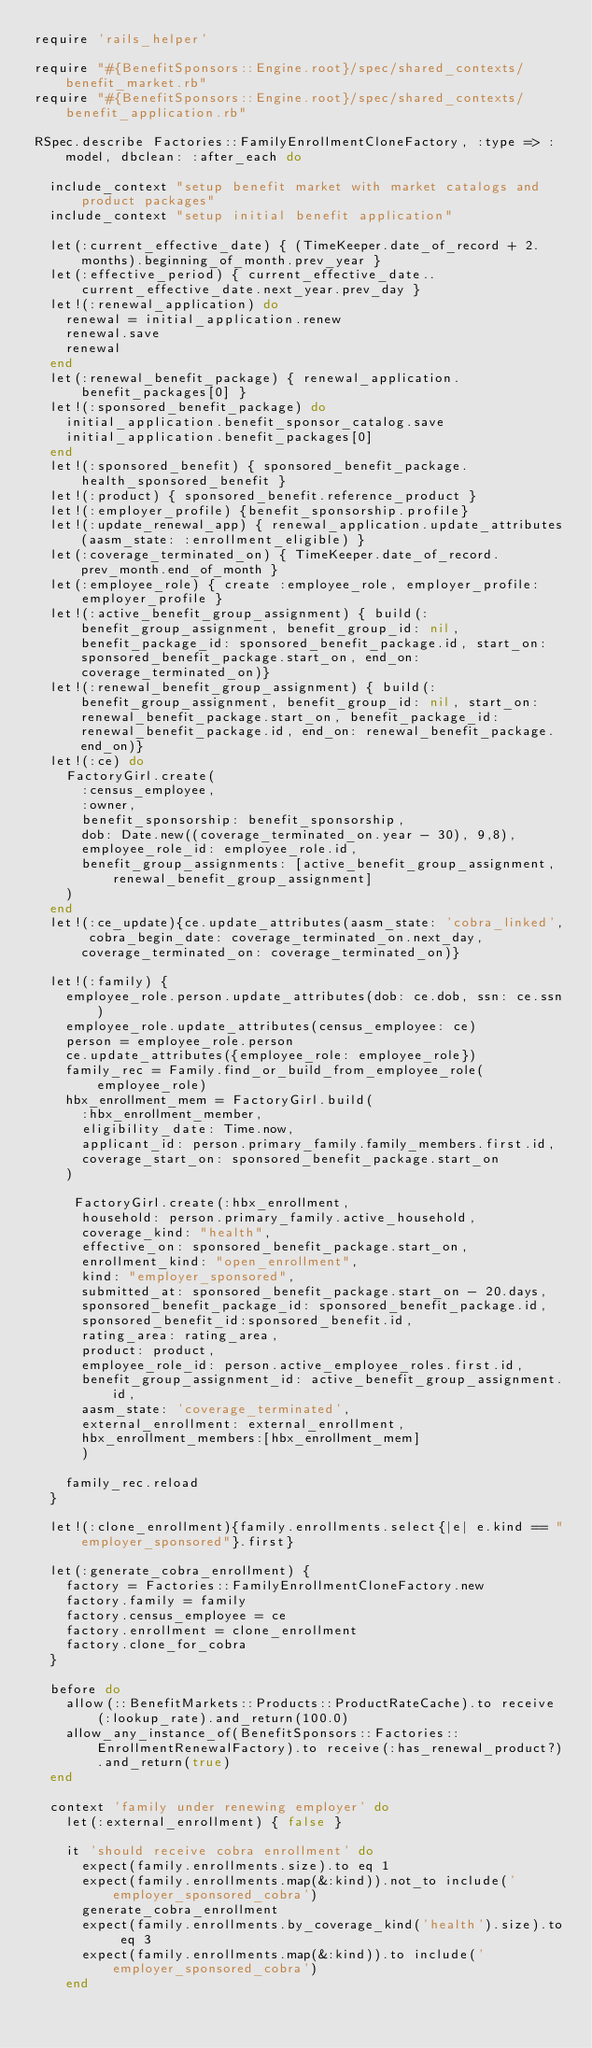<code> <loc_0><loc_0><loc_500><loc_500><_Ruby_>require 'rails_helper'

require "#{BenefitSponsors::Engine.root}/spec/shared_contexts/benefit_market.rb"
require "#{BenefitSponsors::Engine.root}/spec/shared_contexts/benefit_application.rb"

RSpec.describe Factories::FamilyEnrollmentCloneFactory, :type => :model, dbclean: :after_each do

  include_context "setup benefit market with market catalogs and product packages"
  include_context "setup initial benefit application"

  let(:current_effective_date) { (TimeKeeper.date_of_record + 2.months).beginning_of_month.prev_year }
  let(:effective_period) { current_effective_date..current_effective_date.next_year.prev_day }
  let!(:renewal_application) do
    renewal = initial_application.renew
    renewal.save
    renewal
  end
  let(:renewal_benefit_package) { renewal_application.benefit_packages[0] }
  let!(:sponsored_benefit_package) do
    initial_application.benefit_sponsor_catalog.save
    initial_application.benefit_packages[0]
  end
  let!(:sponsored_benefit) { sponsored_benefit_package.health_sponsored_benefit }
  let!(:product) { sponsored_benefit.reference_product }
  let!(:employer_profile) {benefit_sponsorship.profile}
  let!(:update_renewal_app) { renewal_application.update_attributes(aasm_state: :enrollment_eligible) }
  let(:coverage_terminated_on) { TimeKeeper.date_of_record.prev_month.end_of_month }
  let(:employee_role) { create :employee_role, employer_profile: employer_profile }
  let!(:active_benefit_group_assignment) { build(:benefit_group_assignment, benefit_group_id: nil, benefit_package_id: sponsored_benefit_package.id, start_on: sponsored_benefit_package.start_on, end_on: coverage_terminated_on)}
  let!(:renewal_benefit_group_assignment) { build(:benefit_group_assignment, benefit_group_id: nil, start_on: renewal_benefit_package.start_on, benefit_package_id: renewal_benefit_package.id, end_on: renewal_benefit_package.end_on)}
  let!(:ce) do
    FactoryGirl.create(
      :census_employee,
      :owner,
      benefit_sponsorship: benefit_sponsorship,
      dob: Date.new((coverage_terminated_on.year - 30), 9,8),
      employee_role_id: employee_role.id,
      benefit_group_assignments: [active_benefit_group_assignment, renewal_benefit_group_assignment]
    )
  end
  let!(:ce_update){ce.update_attributes(aasm_state: 'cobra_linked', cobra_begin_date: coverage_terminated_on.next_day, coverage_terminated_on: coverage_terminated_on)}

  let!(:family) {
    employee_role.person.update_attributes(dob: ce.dob, ssn: ce.ssn)
    employee_role.update_attributes(census_employee: ce)
    person = employee_role.person
    ce.update_attributes({employee_role: employee_role})
    family_rec = Family.find_or_build_from_employee_role(employee_role)
    hbx_enrollment_mem = FactoryGirl.build(
      :hbx_enrollment_member,
      eligibility_date: Time.now,
      applicant_id: person.primary_family.family_members.first.id,
      coverage_start_on: sponsored_benefit_package.start_on
    )

     FactoryGirl.create(:hbx_enrollment,
      household: person.primary_family.active_household,
      coverage_kind: "health",
      effective_on: sponsored_benefit_package.start_on,
      enrollment_kind: "open_enrollment",
      kind: "employer_sponsored",
      submitted_at: sponsored_benefit_package.start_on - 20.days,
      sponsored_benefit_package_id: sponsored_benefit_package.id,
      sponsored_benefit_id:sponsored_benefit.id,
      rating_area: rating_area,
      product: product,
      employee_role_id: person.active_employee_roles.first.id,
      benefit_group_assignment_id: active_benefit_group_assignment.id,
      aasm_state: 'coverage_terminated',
      external_enrollment: external_enrollment,
      hbx_enrollment_members:[hbx_enrollment_mem]
      )

    family_rec.reload
  }

  let!(:clone_enrollment){family.enrollments.select{|e| e.kind == "employer_sponsored"}.first}

  let(:generate_cobra_enrollment) {
    factory = Factories::FamilyEnrollmentCloneFactory.new
    factory.family = family
    factory.census_employee = ce
    factory.enrollment = clone_enrollment
    factory.clone_for_cobra
  }

  before do
    allow(::BenefitMarkets::Products::ProductRateCache).to receive(:lookup_rate).and_return(100.0)
    allow_any_instance_of(BenefitSponsors::Factories::EnrollmentRenewalFactory).to receive(:has_renewal_product?).and_return(true)
  end

  context 'family under renewing employer' do
    let(:external_enrollment) { false }

    it 'should receive cobra enrollment' do
      expect(family.enrollments.size).to eq 1
      expect(family.enrollments.map(&:kind)).not_to include('employer_sponsored_cobra')
      generate_cobra_enrollment
      expect(family.enrollments.by_coverage_kind('health').size).to eq 3
      expect(family.enrollments.map(&:kind)).to include('employer_sponsored_cobra')
    end
</code> 